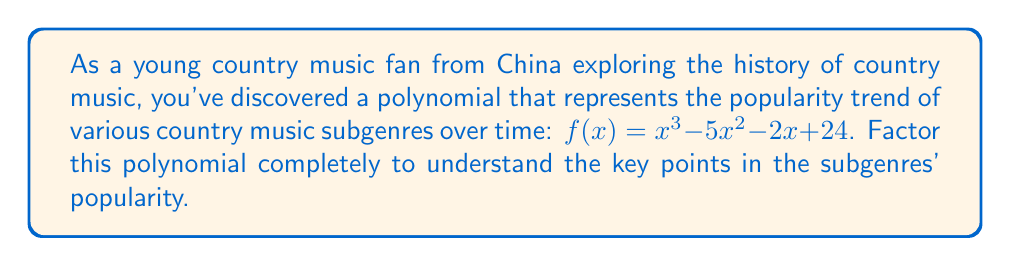Can you answer this question? Let's factor this polynomial step by step:

1) First, we'll check if there are any rational roots using the rational root theorem. The possible rational roots are the factors of the constant term: ±1, ±2, ±3, ±4, ±6, ±8, ±12, ±24.

2) Testing these values, we find that $f(4) = 0$. So $(x-4)$ is a factor.

3) We can now use polynomial long division to divide $f(x)$ by $(x-4)$:

   $$\frac{x^3 - 5x^2 - 2x + 24}{x - 4} = x^2 - x - 6$$

4) So we have: $f(x) = (x-4)(x^2 - x - 6)$

5) Now we need to factor the quadratic term $x^2 - x - 6$. We can do this by finding two numbers that multiply to give -6 and add to give -1. These numbers are -3 and 2.

6) Therefore, $x^2 - x - 6 = (x-3)(x+2)$

7) Putting it all together, we get:

   $f(x) = (x-4)(x-3)(x+2)$

This factorization represents key points in the popularity trend of country music subgenres, with roots at $x=4$, $x=3$, and $x=-2$.
Answer: $(x-4)(x-3)(x+2)$ 